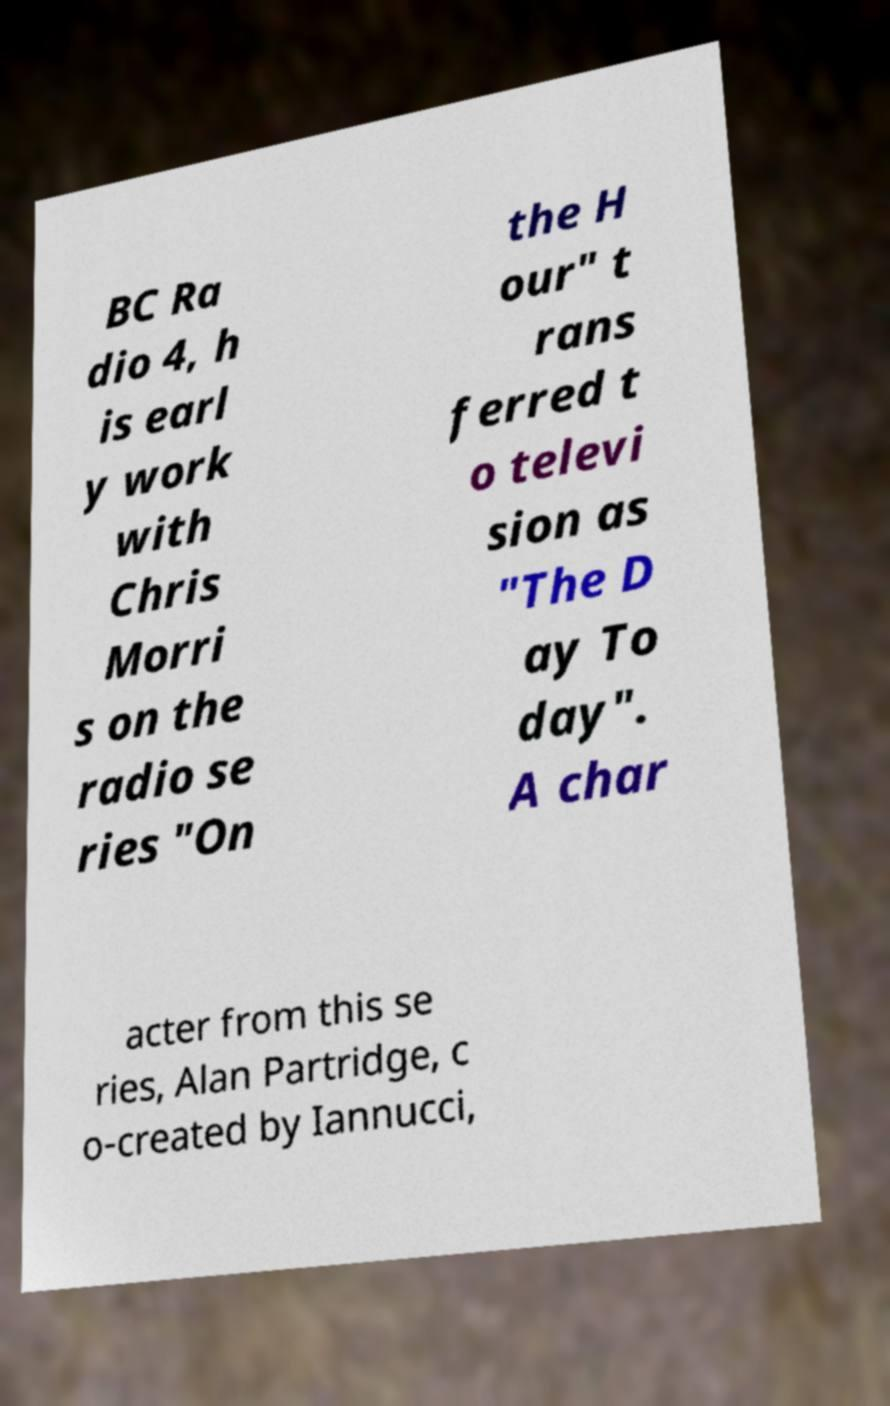For documentation purposes, I need the text within this image transcribed. Could you provide that? BC Ra dio 4, h is earl y work with Chris Morri s on the radio se ries "On the H our" t rans ferred t o televi sion as "The D ay To day". A char acter from this se ries, Alan Partridge, c o-created by Iannucci, 